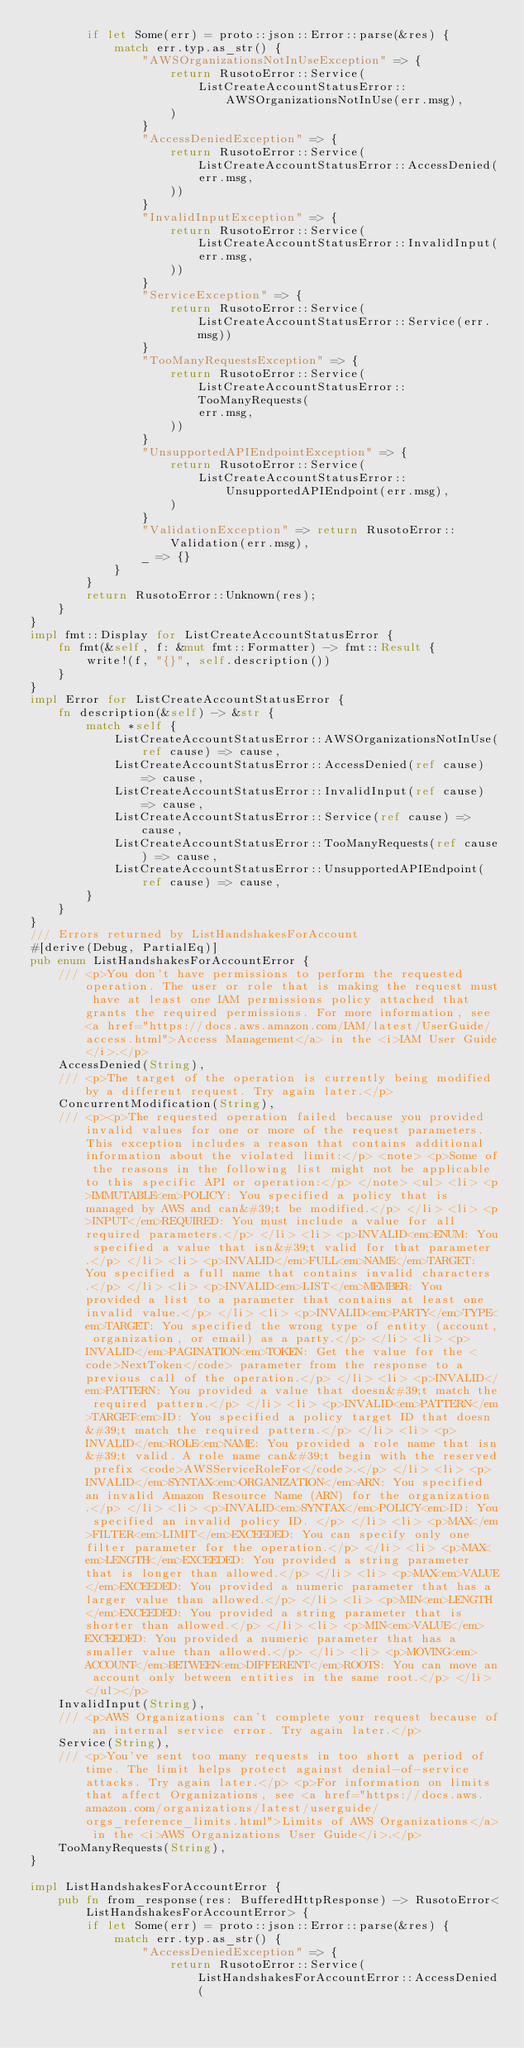Convert code to text. <code><loc_0><loc_0><loc_500><loc_500><_Rust_>        if let Some(err) = proto::json::Error::parse(&res) {
            match err.typ.as_str() {
                "AWSOrganizationsNotInUseException" => {
                    return RusotoError::Service(
                        ListCreateAccountStatusError::AWSOrganizationsNotInUse(err.msg),
                    )
                }
                "AccessDeniedException" => {
                    return RusotoError::Service(ListCreateAccountStatusError::AccessDenied(
                        err.msg,
                    ))
                }
                "InvalidInputException" => {
                    return RusotoError::Service(ListCreateAccountStatusError::InvalidInput(
                        err.msg,
                    ))
                }
                "ServiceException" => {
                    return RusotoError::Service(ListCreateAccountStatusError::Service(err.msg))
                }
                "TooManyRequestsException" => {
                    return RusotoError::Service(ListCreateAccountStatusError::TooManyRequests(
                        err.msg,
                    ))
                }
                "UnsupportedAPIEndpointException" => {
                    return RusotoError::Service(
                        ListCreateAccountStatusError::UnsupportedAPIEndpoint(err.msg),
                    )
                }
                "ValidationException" => return RusotoError::Validation(err.msg),
                _ => {}
            }
        }
        return RusotoError::Unknown(res);
    }
}
impl fmt::Display for ListCreateAccountStatusError {
    fn fmt(&self, f: &mut fmt::Formatter) -> fmt::Result {
        write!(f, "{}", self.description())
    }
}
impl Error for ListCreateAccountStatusError {
    fn description(&self) -> &str {
        match *self {
            ListCreateAccountStatusError::AWSOrganizationsNotInUse(ref cause) => cause,
            ListCreateAccountStatusError::AccessDenied(ref cause) => cause,
            ListCreateAccountStatusError::InvalidInput(ref cause) => cause,
            ListCreateAccountStatusError::Service(ref cause) => cause,
            ListCreateAccountStatusError::TooManyRequests(ref cause) => cause,
            ListCreateAccountStatusError::UnsupportedAPIEndpoint(ref cause) => cause,
        }
    }
}
/// Errors returned by ListHandshakesForAccount
#[derive(Debug, PartialEq)]
pub enum ListHandshakesForAccountError {
    /// <p>You don't have permissions to perform the requested operation. The user or role that is making the request must have at least one IAM permissions policy attached that grants the required permissions. For more information, see <a href="https://docs.aws.amazon.com/IAM/latest/UserGuide/access.html">Access Management</a> in the <i>IAM User Guide</i>.</p>
    AccessDenied(String),
    /// <p>The target of the operation is currently being modified by a different request. Try again later.</p>
    ConcurrentModification(String),
    /// <p><p>The requested operation failed because you provided invalid values for one or more of the request parameters. This exception includes a reason that contains additional information about the violated limit:</p> <note> <p>Some of the reasons in the following list might not be applicable to this specific API or operation:</p> </note> <ul> <li> <p>IMMUTABLE<em>POLICY: You specified a policy that is managed by AWS and can&#39;t be modified.</p> </li> <li> <p>INPUT</em>REQUIRED: You must include a value for all required parameters.</p> </li> <li> <p>INVALID<em>ENUM: You specified a value that isn&#39;t valid for that parameter.</p> </li> <li> <p>INVALID</em>FULL<em>NAME</em>TARGET: You specified a full name that contains invalid characters.</p> </li> <li> <p>INVALID<em>LIST</em>MEMBER: You provided a list to a parameter that contains at least one invalid value.</p> </li> <li> <p>INVALID<em>PARTY</em>TYPE<em>TARGET: You specified the wrong type of entity (account, organization, or email) as a party.</p> </li> <li> <p>INVALID</em>PAGINATION<em>TOKEN: Get the value for the <code>NextToken</code> parameter from the response to a previous call of the operation.</p> </li> <li> <p>INVALID</em>PATTERN: You provided a value that doesn&#39;t match the required pattern.</p> </li> <li> <p>INVALID<em>PATTERN</em>TARGET<em>ID: You specified a policy target ID that doesn&#39;t match the required pattern.</p> </li> <li> <p>INVALID</em>ROLE<em>NAME: You provided a role name that isn&#39;t valid. A role name can&#39;t begin with the reserved prefix <code>AWSServiceRoleFor</code>.</p> </li> <li> <p>INVALID</em>SYNTAX<em>ORGANIZATION</em>ARN: You specified an invalid Amazon Resource Name (ARN) for the organization.</p> </li> <li> <p>INVALID<em>SYNTAX</em>POLICY<em>ID: You specified an invalid policy ID. </p> </li> <li> <p>MAX</em>FILTER<em>LIMIT</em>EXCEEDED: You can specify only one filter parameter for the operation.</p> </li> <li> <p>MAX<em>LENGTH</em>EXCEEDED: You provided a string parameter that is longer than allowed.</p> </li> <li> <p>MAX<em>VALUE</em>EXCEEDED: You provided a numeric parameter that has a larger value than allowed.</p> </li> <li> <p>MIN<em>LENGTH</em>EXCEEDED: You provided a string parameter that is shorter than allowed.</p> </li> <li> <p>MIN<em>VALUE</em>EXCEEDED: You provided a numeric parameter that has a smaller value than allowed.</p> </li> <li> <p>MOVING<em>ACCOUNT</em>BETWEEN<em>DIFFERENT</em>ROOTS: You can move an account only between entities in the same root.</p> </li> </ul></p>
    InvalidInput(String),
    /// <p>AWS Organizations can't complete your request because of an internal service error. Try again later.</p>
    Service(String),
    /// <p>You've sent too many requests in too short a period of time. The limit helps protect against denial-of-service attacks. Try again later.</p> <p>For information on limits that affect Organizations, see <a href="https://docs.aws.amazon.com/organizations/latest/userguide/orgs_reference_limits.html">Limits of AWS Organizations</a> in the <i>AWS Organizations User Guide</i>.</p>
    TooManyRequests(String),
}

impl ListHandshakesForAccountError {
    pub fn from_response(res: BufferedHttpResponse) -> RusotoError<ListHandshakesForAccountError> {
        if let Some(err) = proto::json::Error::parse(&res) {
            match err.typ.as_str() {
                "AccessDeniedException" => {
                    return RusotoError::Service(ListHandshakesForAccountError::AccessDenied(</code> 